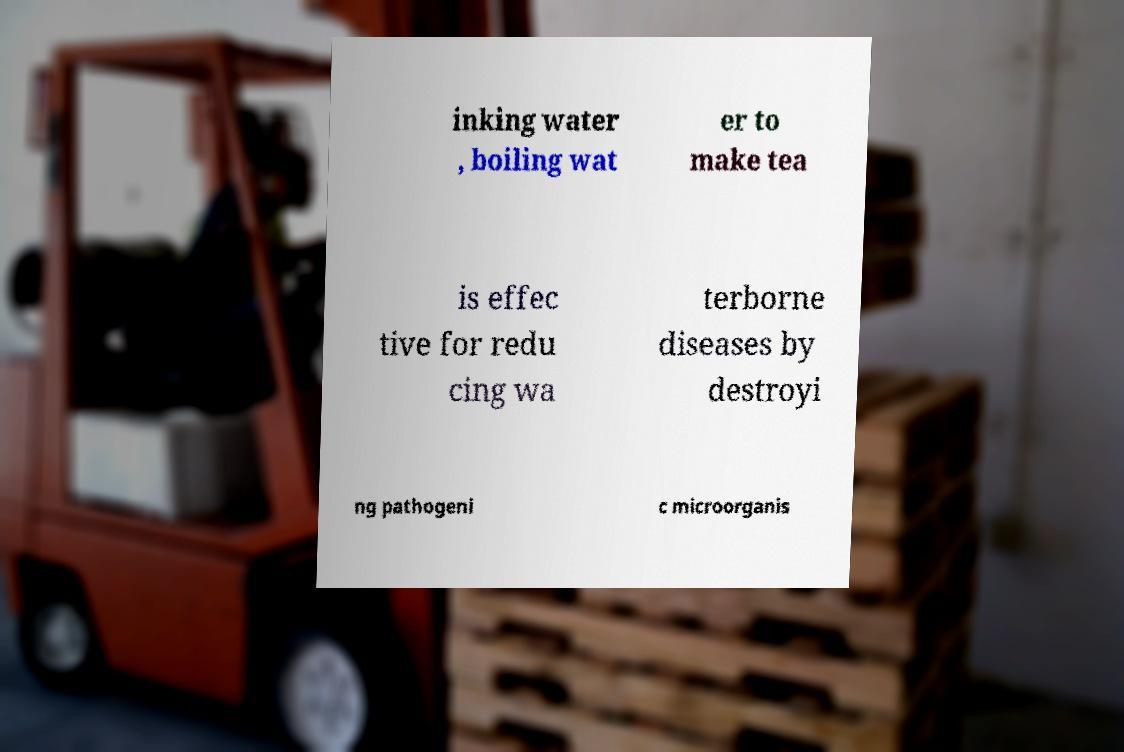Can you read and provide the text displayed in the image?This photo seems to have some interesting text. Can you extract and type it out for me? inking water , boiling wat er to make tea is effec tive for redu cing wa terborne diseases by destroyi ng pathogeni c microorganis 